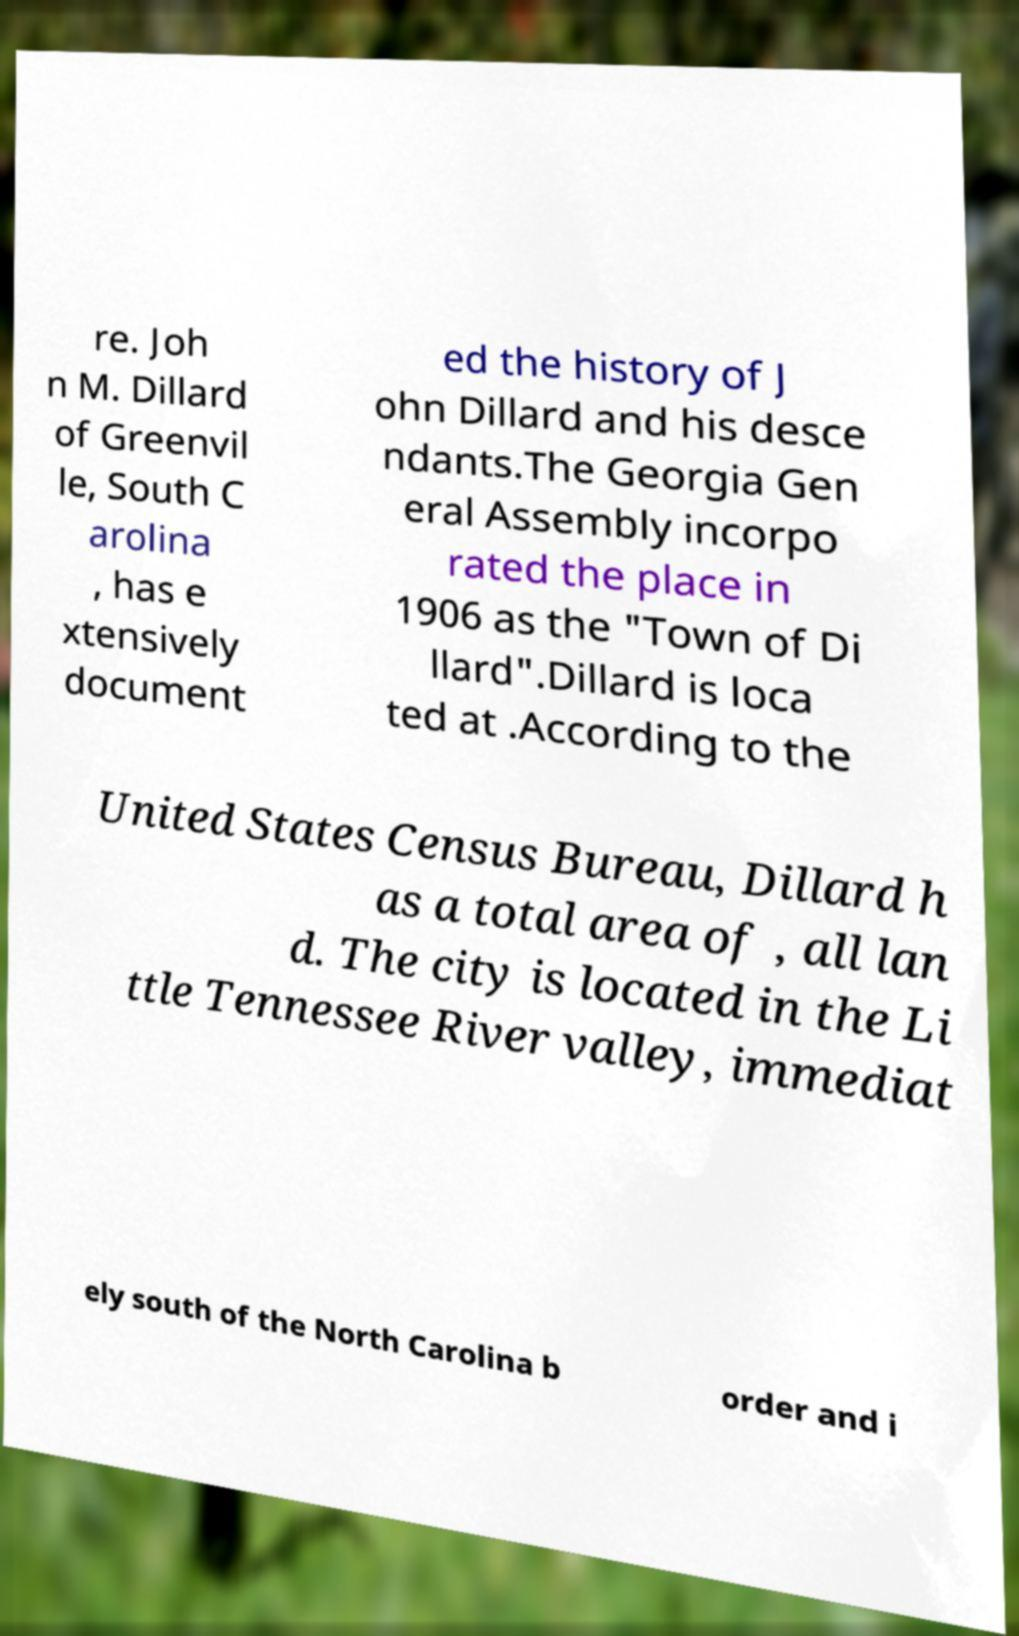For documentation purposes, I need the text within this image transcribed. Could you provide that? re. Joh n M. Dillard of Greenvil le, South C arolina , has e xtensively document ed the history of J ohn Dillard and his desce ndants.The Georgia Gen eral Assembly incorpo rated the place in 1906 as the "Town of Di llard".Dillard is loca ted at .According to the United States Census Bureau, Dillard h as a total area of , all lan d. The city is located in the Li ttle Tennessee River valley, immediat ely south of the North Carolina b order and i 